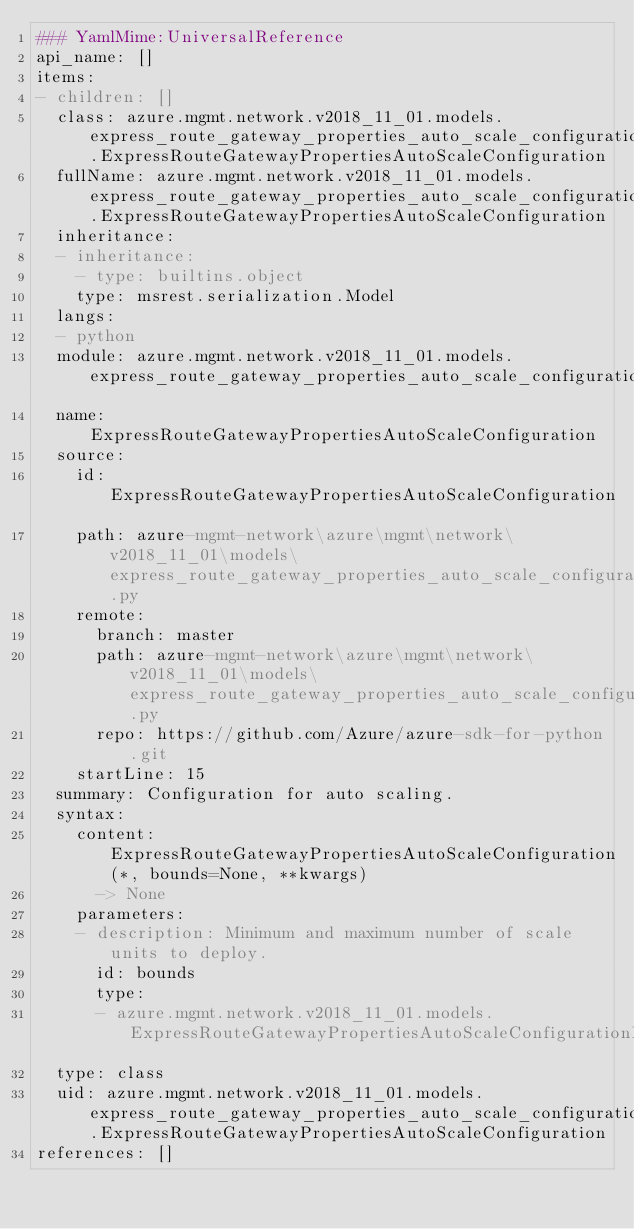<code> <loc_0><loc_0><loc_500><loc_500><_YAML_>### YamlMime:UniversalReference
api_name: []
items:
- children: []
  class: azure.mgmt.network.v2018_11_01.models.express_route_gateway_properties_auto_scale_configuration_py3.ExpressRouteGatewayPropertiesAutoScaleConfiguration
  fullName: azure.mgmt.network.v2018_11_01.models.express_route_gateway_properties_auto_scale_configuration_py3.ExpressRouteGatewayPropertiesAutoScaleConfiguration
  inheritance:
  - inheritance:
    - type: builtins.object
    type: msrest.serialization.Model
  langs:
  - python
  module: azure.mgmt.network.v2018_11_01.models.express_route_gateway_properties_auto_scale_configuration_py3
  name: ExpressRouteGatewayPropertiesAutoScaleConfiguration
  source:
    id: ExpressRouteGatewayPropertiesAutoScaleConfiguration
    path: azure-mgmt-network\azure\mgmt\network\v2018_11_01\models\express_route_gateway_properties_auto_scale_configuration_py3.py
    remote:
      branch: master
      path: azure-mgmt-network\azure\mgmt\network\v2018_11_01\models\express_route_gateway_properties_auto_scale_configuration_py3.py
      repo: https://github.com/Azure/azure-sdk-for-python.git
    startLine: 15
  summary: Configuration for auto scaling.
  syntax:
    content: ExpressRouteGatewayPropertiesAutoScaleConfiguration(*, bounds=None, **kwargs)
      -> None
    parameters:
    - description: Minimum and maximum number of scale units to deploy.
      id: bounds
      type:
      - azure.mgmt.network.v2018_11_01.models.ExpressRouteGatewayPropertiesAutoScaleConfigurationBounds
  type: class
  uid: azure.mgmt.network.v2018_11_01.models.express_route_gateway_properties_auto_scale_configuration_py3.ExpressRouteGatewayPropertiesAutoScaleConfiguration
references: []
</code> 